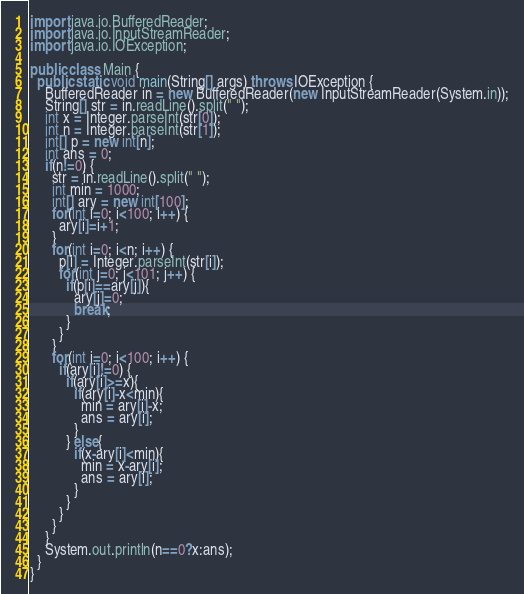Convert code to text. <code><loc_0><loc_0><loc_500><loc_500><_Java_>import java.io.BufferedReader;
import java.io.InputStreamReader;
import java.io.IOException;

public class Main {
  public static void main(String[] args) throws IOException {
    BufferedReader in = new BufferedReader(new InputStreamReader(System.in));
    String[] str = in.readLine().split(" ");
    int x = Integer.parseInt(str[0]);
    int n = Integer.parseInt(str[1]);
    int[] p = new int[n];
    int ans = 0;
    if(n!=0) {
      str = in.readLine().split(" ");
      int min = 1000;
      int[] ary = new int[100];
      for(int i=0; i<100; i++) {
        ary[i]=i+1;
      }
      for(int i=0; i<n; i++) {
        p[i] = Integer.parseInt(str[i]);
        for(int j=0; j<101; j++) {
          if(p[i]==ary[j]){
            ary[j]=0;
            break;
          }
        }
      }
      for(int i=0; i<100; i++) {
        if(ary[i]!=0) {
          if(ary[i]>=x){
            if(ary[i]-x<min){
              min = ary[i]-x;
              ans = ary[i];
            }
          } else{
            if(x-ary[i]<min){
              min = x-ary[i];
              ans = ary[i];
            }
          }
        }
      }
    }
    System.out.println(n==0?x:ans);
  }
}</code> 